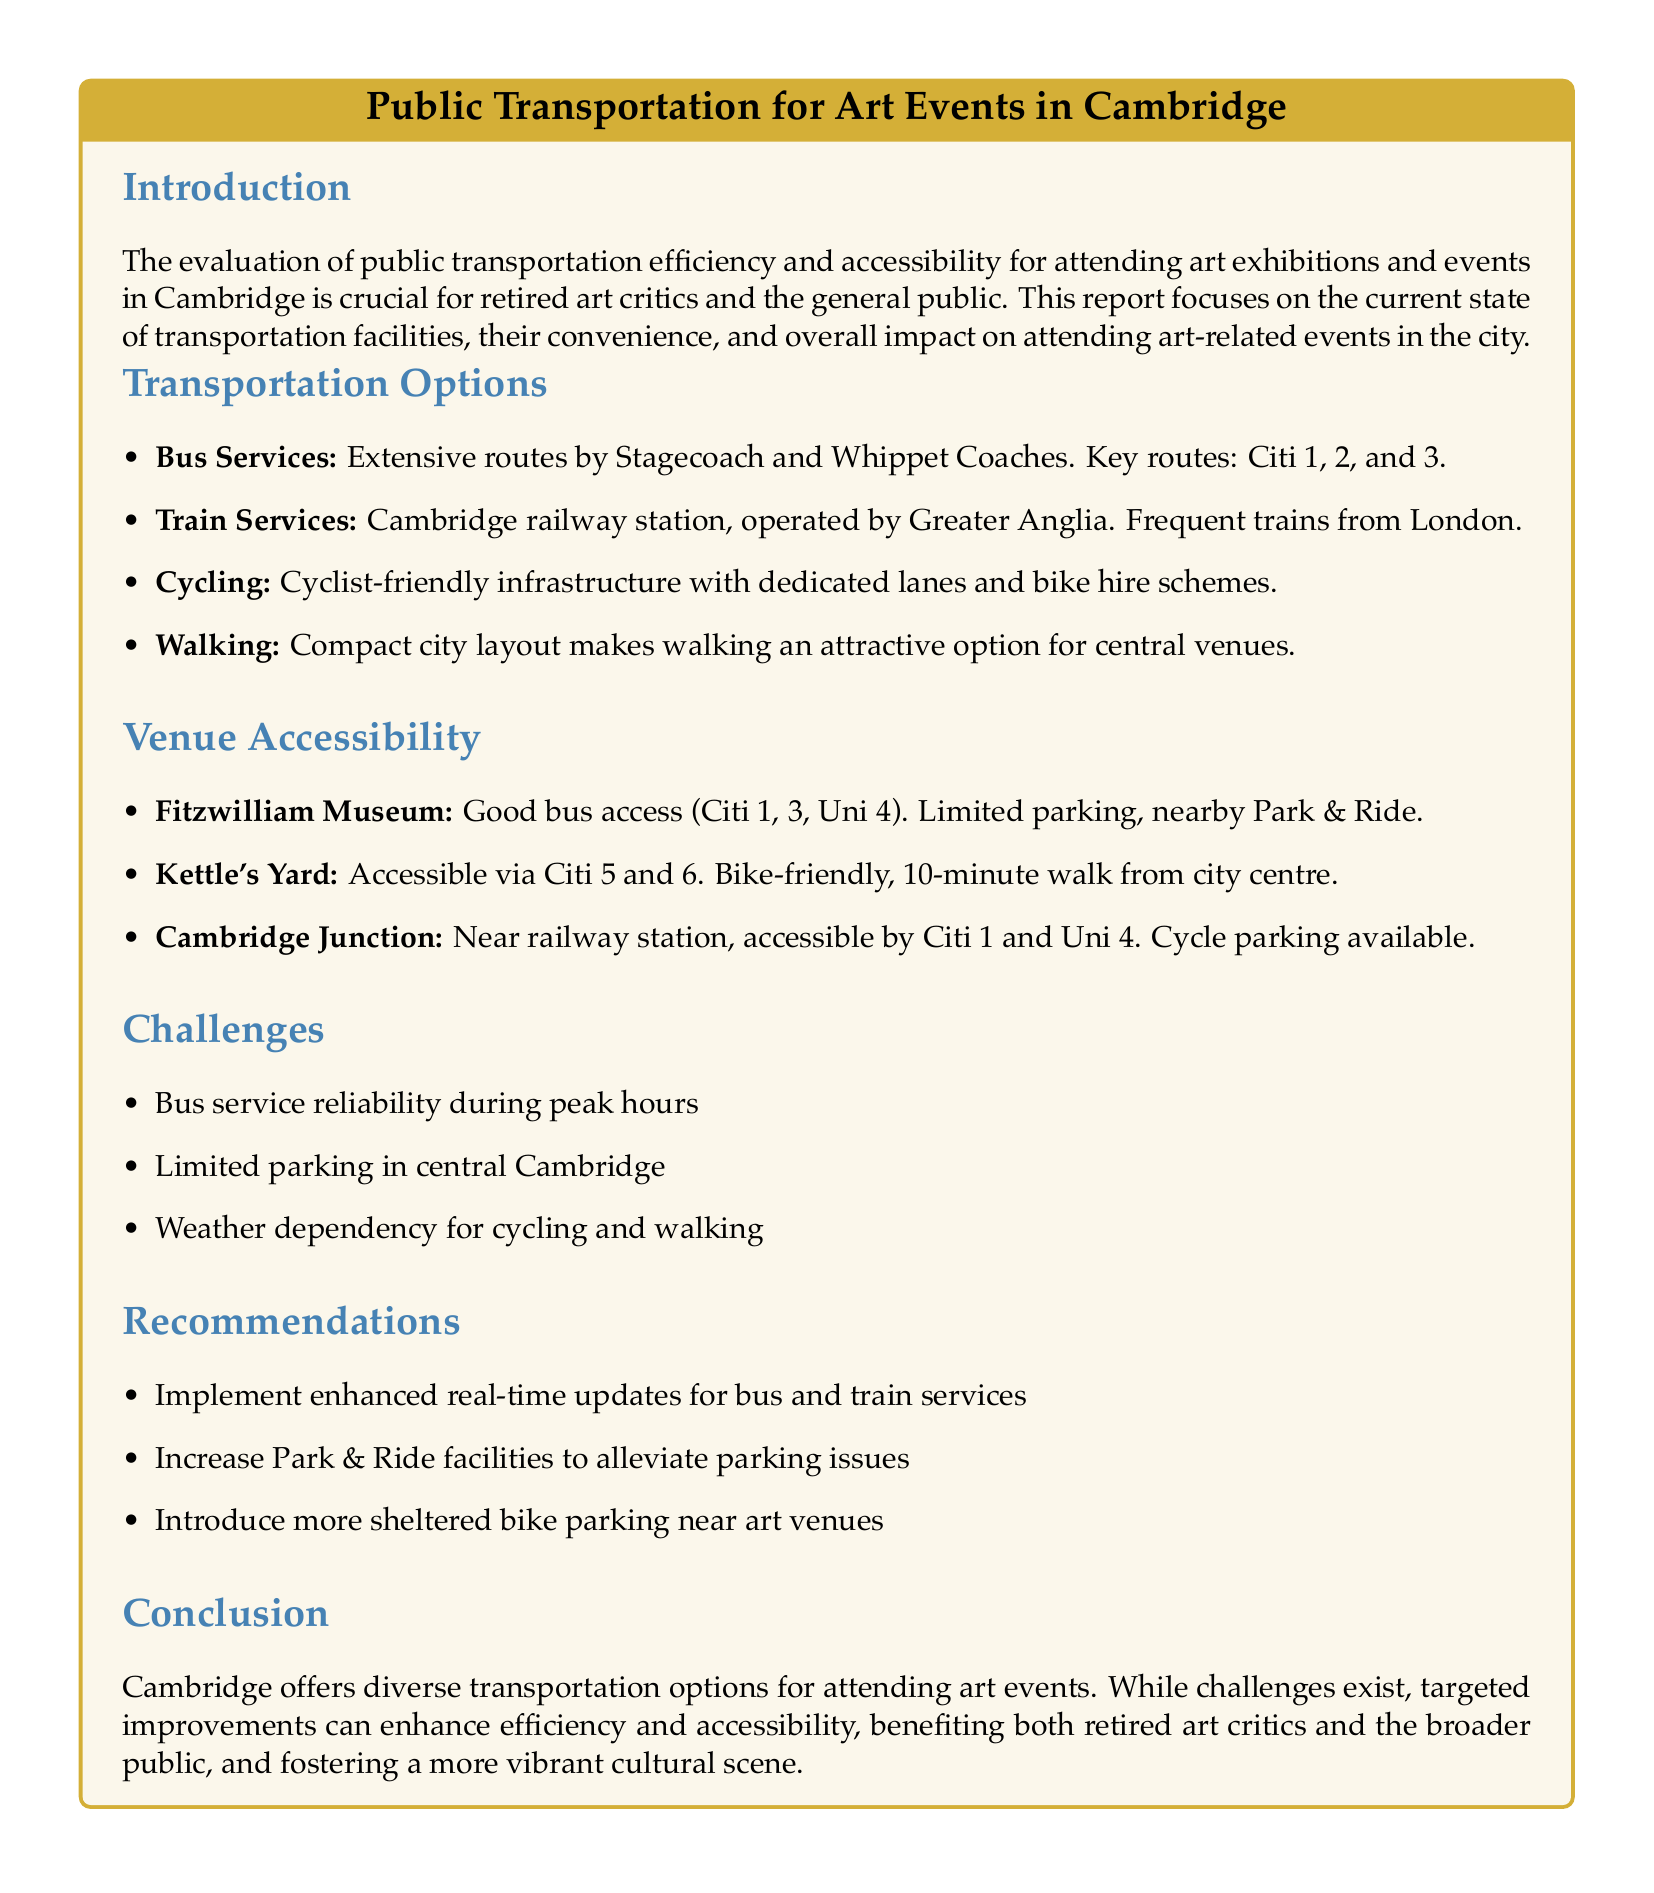what are the key routes for bus services? The document lists key bus routes as Citi 1, 2, and 3.
Answer: Citi 1, 2, and 3 which organization operates the train services? The report states that train services are operated by Greater Anglia.
Answer: Greater Anglia how is cycling described in the transportation options? The document mentions that there is cyclist-friendly infrastructure with dedicated lanes and bike hire schemes.
Answer: Cyclist-friendly infrastructure what is a challenge for public transportation mentioned? One of the challenges highlighted is bus service reliability during peak hours.
Answer: Bus service reliability how accessible is the Fitzwilliam Museum via public transport? It has good bus access (Citi 1, 3, Uni 4) and limited parking, with nearby Park & Ride.
Answer: Good bus access what recommendations does the report suggest regarding parking? The report recommends increasing Park & Ride facilities to alleviate parking issues.
Answer: Increase Park & Ride facilities how long is the walk from Kettle's Yard to the city centre? The report mentions that it is a 10-minute walk from the city centre to Kettle's Yard.
Answer: 10-minute walk which specific venue is near the railway station? The document states that Cambridge Junction is near the railway station.
Answer: Cambridge Junction what overall benefit does the report suggest for improving public transportation? The report concludes that targeted improvements can enhance efficiency and accessibility, benefiting both retired art critics and the broader public.
Answer: Enhance efficiency and accessibility 